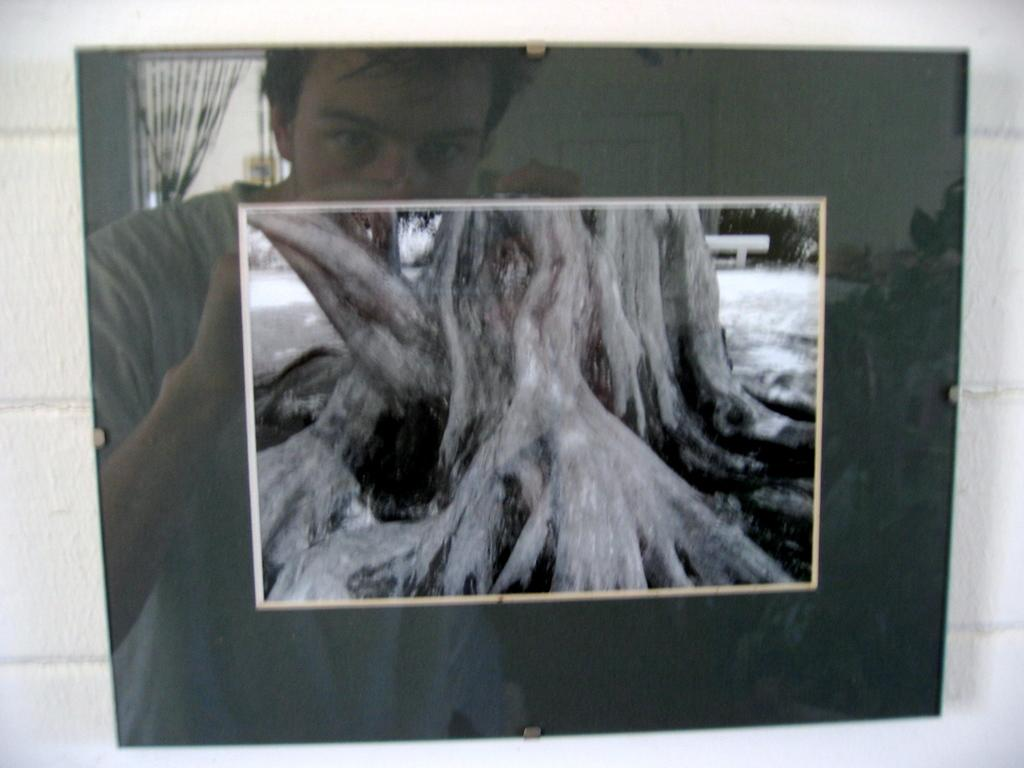What can be seen in the image that resembles a person? There is a reflection of a person in the image. What is the main subject of the photograph in the image? The photograph in the image is of a bark. How is the photograph displayed in the image? The photograph is attached to a glass window. What type of pancake is being traded in the image? There is no pancake or trade present in the image. How does the person in the reflection join the group in the image? The reflection of the person does not join any group in the image, as it is a reflection and not an actual person. 